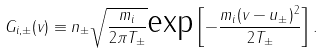Convert formula to latex. <formula><loc_0><loc_0><loc_500><loc_500>G _ { i , \pm } ( v ) \equiv n _ { \pm } \sqrt { \frac { m _ { i } } { 2 \pi T _ { \pm } } } \text {exp} \left [ - \frac { m _ { i } ( v - u _ { \pm } ) ^ { 2 } } { 2 T _ { \pm } } \right ] .</formula> 